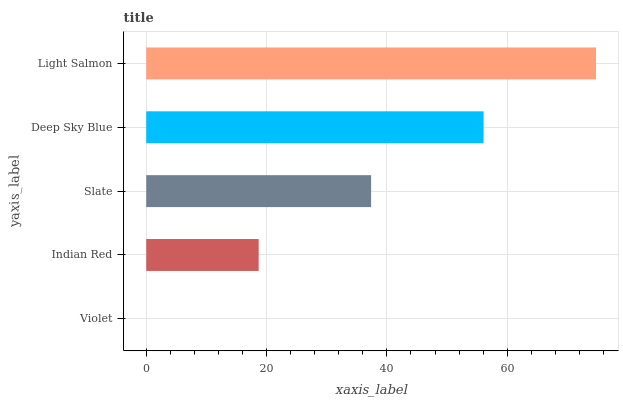Is Violet the minimum?
Answer yes or no. Yes. Is Light Salmon the maximum?
Answer yes or no. Yes. Is Indian Red the minimum?
Answer yes or no. No. Is Indian Red the maximum?
Answer yes or no. No. Is Indian Red greater than Violet?
Answer yes or no. Yes. Is Violet less than Indian Red?
Answer yes or no. Yes. Is Violet greater than Indian Red?
Answer yes or no. No. Is Indian Red less than Violet?
Answer yes or no. No. Is Slate the high median?
Answer yes or no. Yes. Is Slate the low median?
Answer yes or no. Yes. Is Indian Red the high median?
Answer yes or no. No. Is Light Salmon the low median?
Answer yes or no. No. 